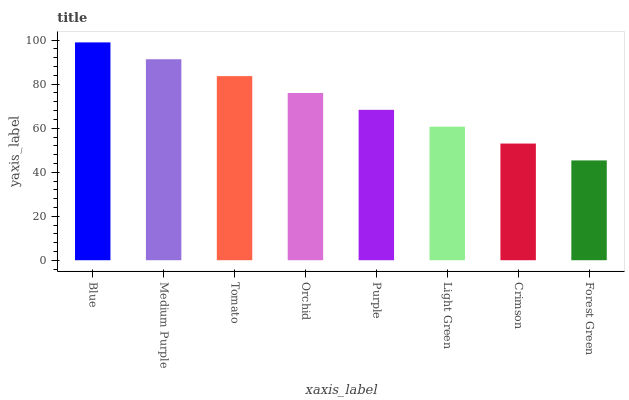Is Medium Purple the minimum?
Answer yes or no. No. Is Medium Purple the maximum?
Answer yes or no. No. Is Blue greater than Medium Purple?
Answer yes or no. Yes. Is Medium Purple less than Blue?
Answer yes or no. Yes. Is Medium Purple greater than Blue?
Answer yes or no. No. Is Blue less than Medium Purple?
Answer yes or no. No. Is Orchid the high median?
Answer yes or no. Yes. Is Purple the low median?
Answer yes or no. Yes. Is Purple the high median?
Answer yes or no. No. Is Light Green the low median?
Answer yes or no. No. 